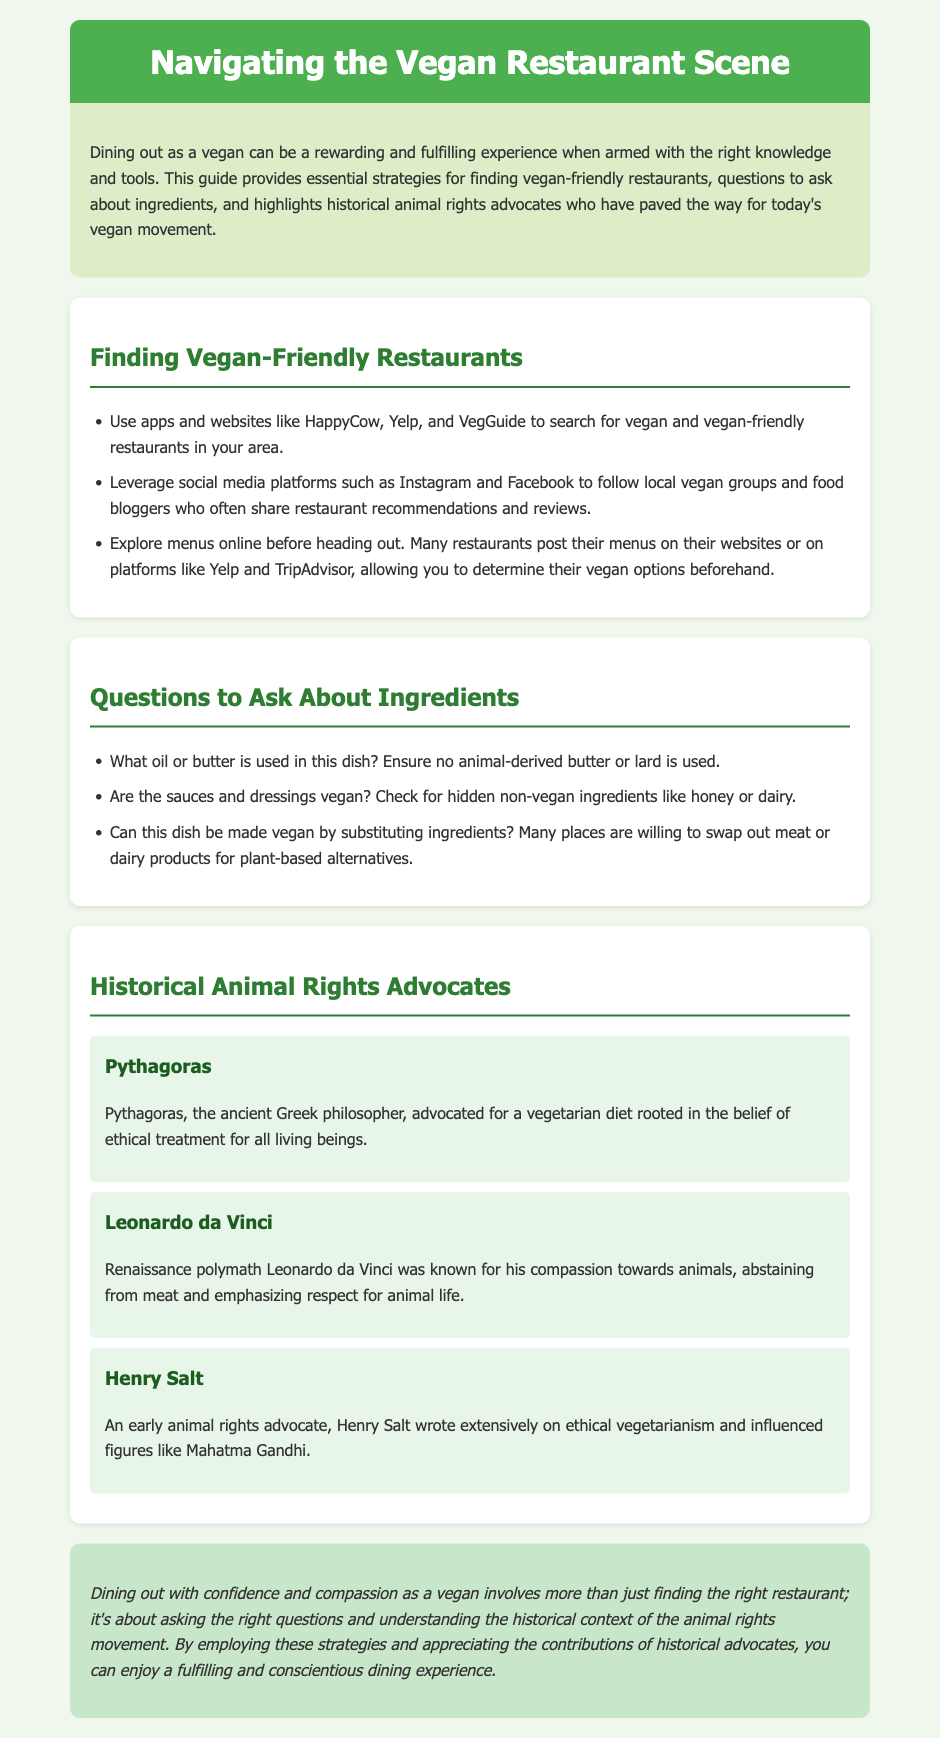What platforms can be used to find vegan-friendly restaurants? The guide mentions using apps and websites like HappyCow, Yelp, and VegGuide for searching vegan-friendly restaurants.
Answer: HappyCow, Yelp, VegGuide What should you ask about the oil or butter used in a dish? The guide advises asking what oil or butter is used in the dish to ensure no animal-derived products are included.
Answer: Animal-derived Who was known for his compassion towards animals and abstained from meat? The historical figure Leonardo da Vinci is noted for his compassion towards animals and abstaining from meat.
Answer: Leonardo da Vinci What ancient philosopher advocated for a vegetarian diet? Pythagoras is recognized as the ancient philosopher who advocated for a vegetarian diet.
Answer: Pythagoras What is one ingredient type to check for in sauces and dressings? The guide specifically mentions checking for hidden non-vegan ingredients like honey or dairy in sauces and dressings.
Answer: Honey Can dishes be modified to be vegan? The guide suggests asking if certain dishes can be made vegan by substituting ingredients.
Answer: Yes What ethical belief did Pythagoras promote? Pythagoras promoted the ethical treatment of all living beings.
Answer: Ethical treatment Which advocate influenced figures like Mahatma Gandhi? Henry Salt is mentioned as an early animal rights advocate who influenced figures like Mahatma Gandhi.
Answer: Henry Salt 